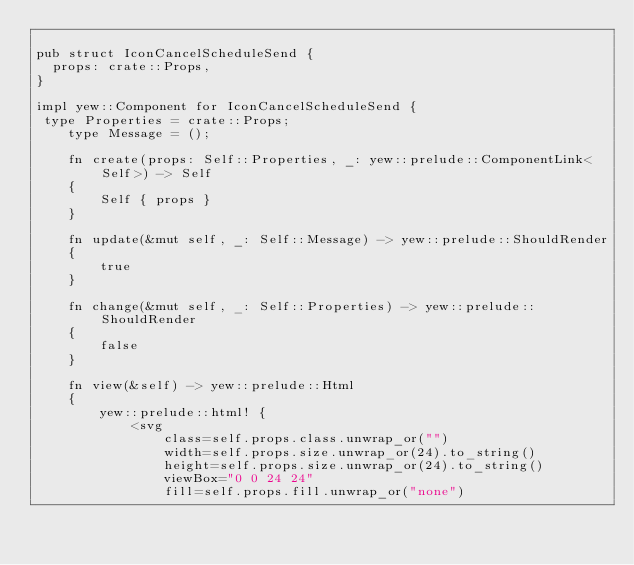Convert code to text. <code><loc_0><loc_0><loc_500><loc_500><_Rust_>
pub struct IconCancelScheduleSend {
  props: crate::Props,
}

impl yew::Component for IconCancelScheduleSend {
 type Properties = crate::Props;
    type Message = ();

    fn create(props: Self::Properties, _: yew::prelude::ComponentLink<Self>) -> Self
    {
        Self { props }
    }

    fn update(&mut self, _: Self::Message) -> yew::prelude::ShouldRender
    {
        true
    }

    fn change(&mut self, _: Self::Properties) -> yew::prelude::ShouldRender
    {
        false
    }

    fn view(&self) -> yew::prelude::Html
    {
        yew::prelude::html! {
            <svg
                class=self.props.class.unwrap_or("")
                width=self.props.size.unwrap_or(24).to_string()
                height=self.props.size.unwrap_or(24).to_string()
                viewBox="0 0 24 24"
                fill=self.props.fill.unwrap_or("none")</code> 